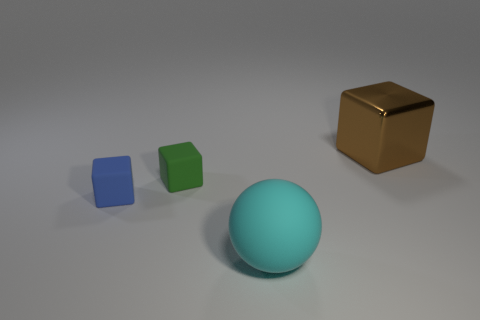Subtract all red cubes. Subtract all gray spheres. How many cubes are left? 3 Add 4 big rubber spheres. How many objects exist? 8 Subtract all balls. How many objects are left? 3 Add 4 big yellow shiny things. How many big yellow shiny things exist? 4 Subtract 0 red cylinders. How many objects are left? 4 Subtract all big cyan metallic things. Subtract all big cyan objects. How many objects are left? 3 Add 3 metal cubes. How many metal cubes are left? 4 